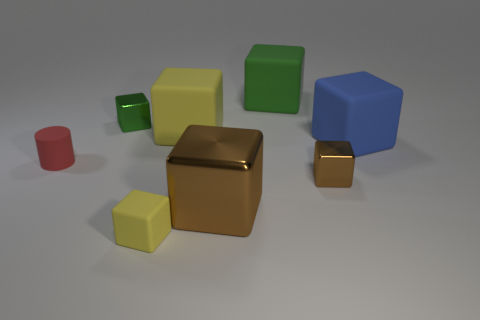Subtract 1 blocks. How many blocks are left? 6 Subtract all yellow blocks. How many blocks are left? 5 Subtract all big green blocks. How many blocks are left? 6 Subtract all red blocks. Subtract all red spheres. How many blocks are left? 7 Add 1 small brown cubes. How many objects exist? 9 Subtract all cubes. How many objects are left? 1 Add 8 blue cubes. How many blue cubes exist? 9 Subtract 0 green cylinders. How many objects are left? 8 Subtract all small matte objects. Subtract all brown metallic things. How many objects are left? 4 Add 4 big blue things. How many big blue things are left? 5 